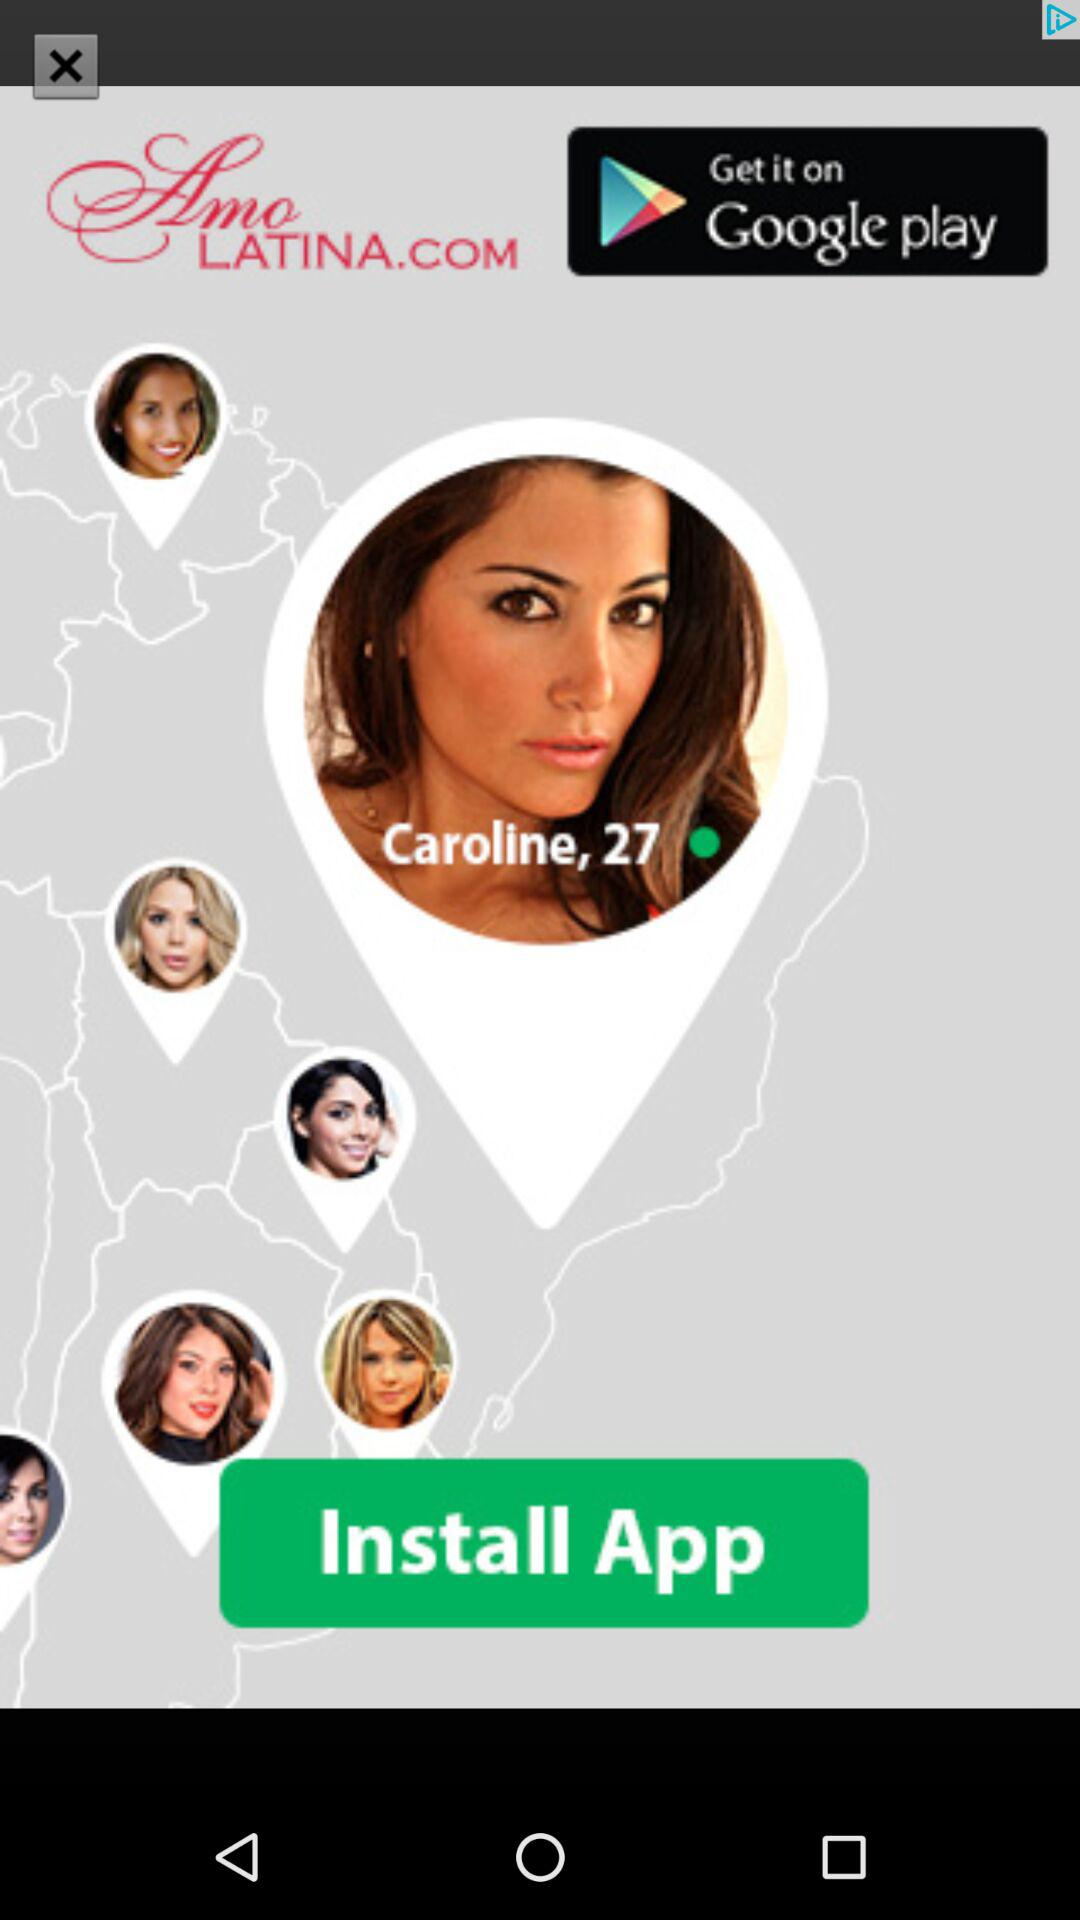What is the user name? The user name is Caroline. 